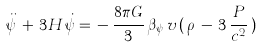<formula> <loc_0><loc_0><loc_500><loc_500>\ddot { \psi } \, + \, 3 H \, \dot { \psi } = \, - \, \frac { 8 \pi G } { 3 } \, { \beta } _ { \psi } \, v \, ( \, \rho \, - \, 3 \, \frac { P } { c ^ { 2 } } \, )</formula> 